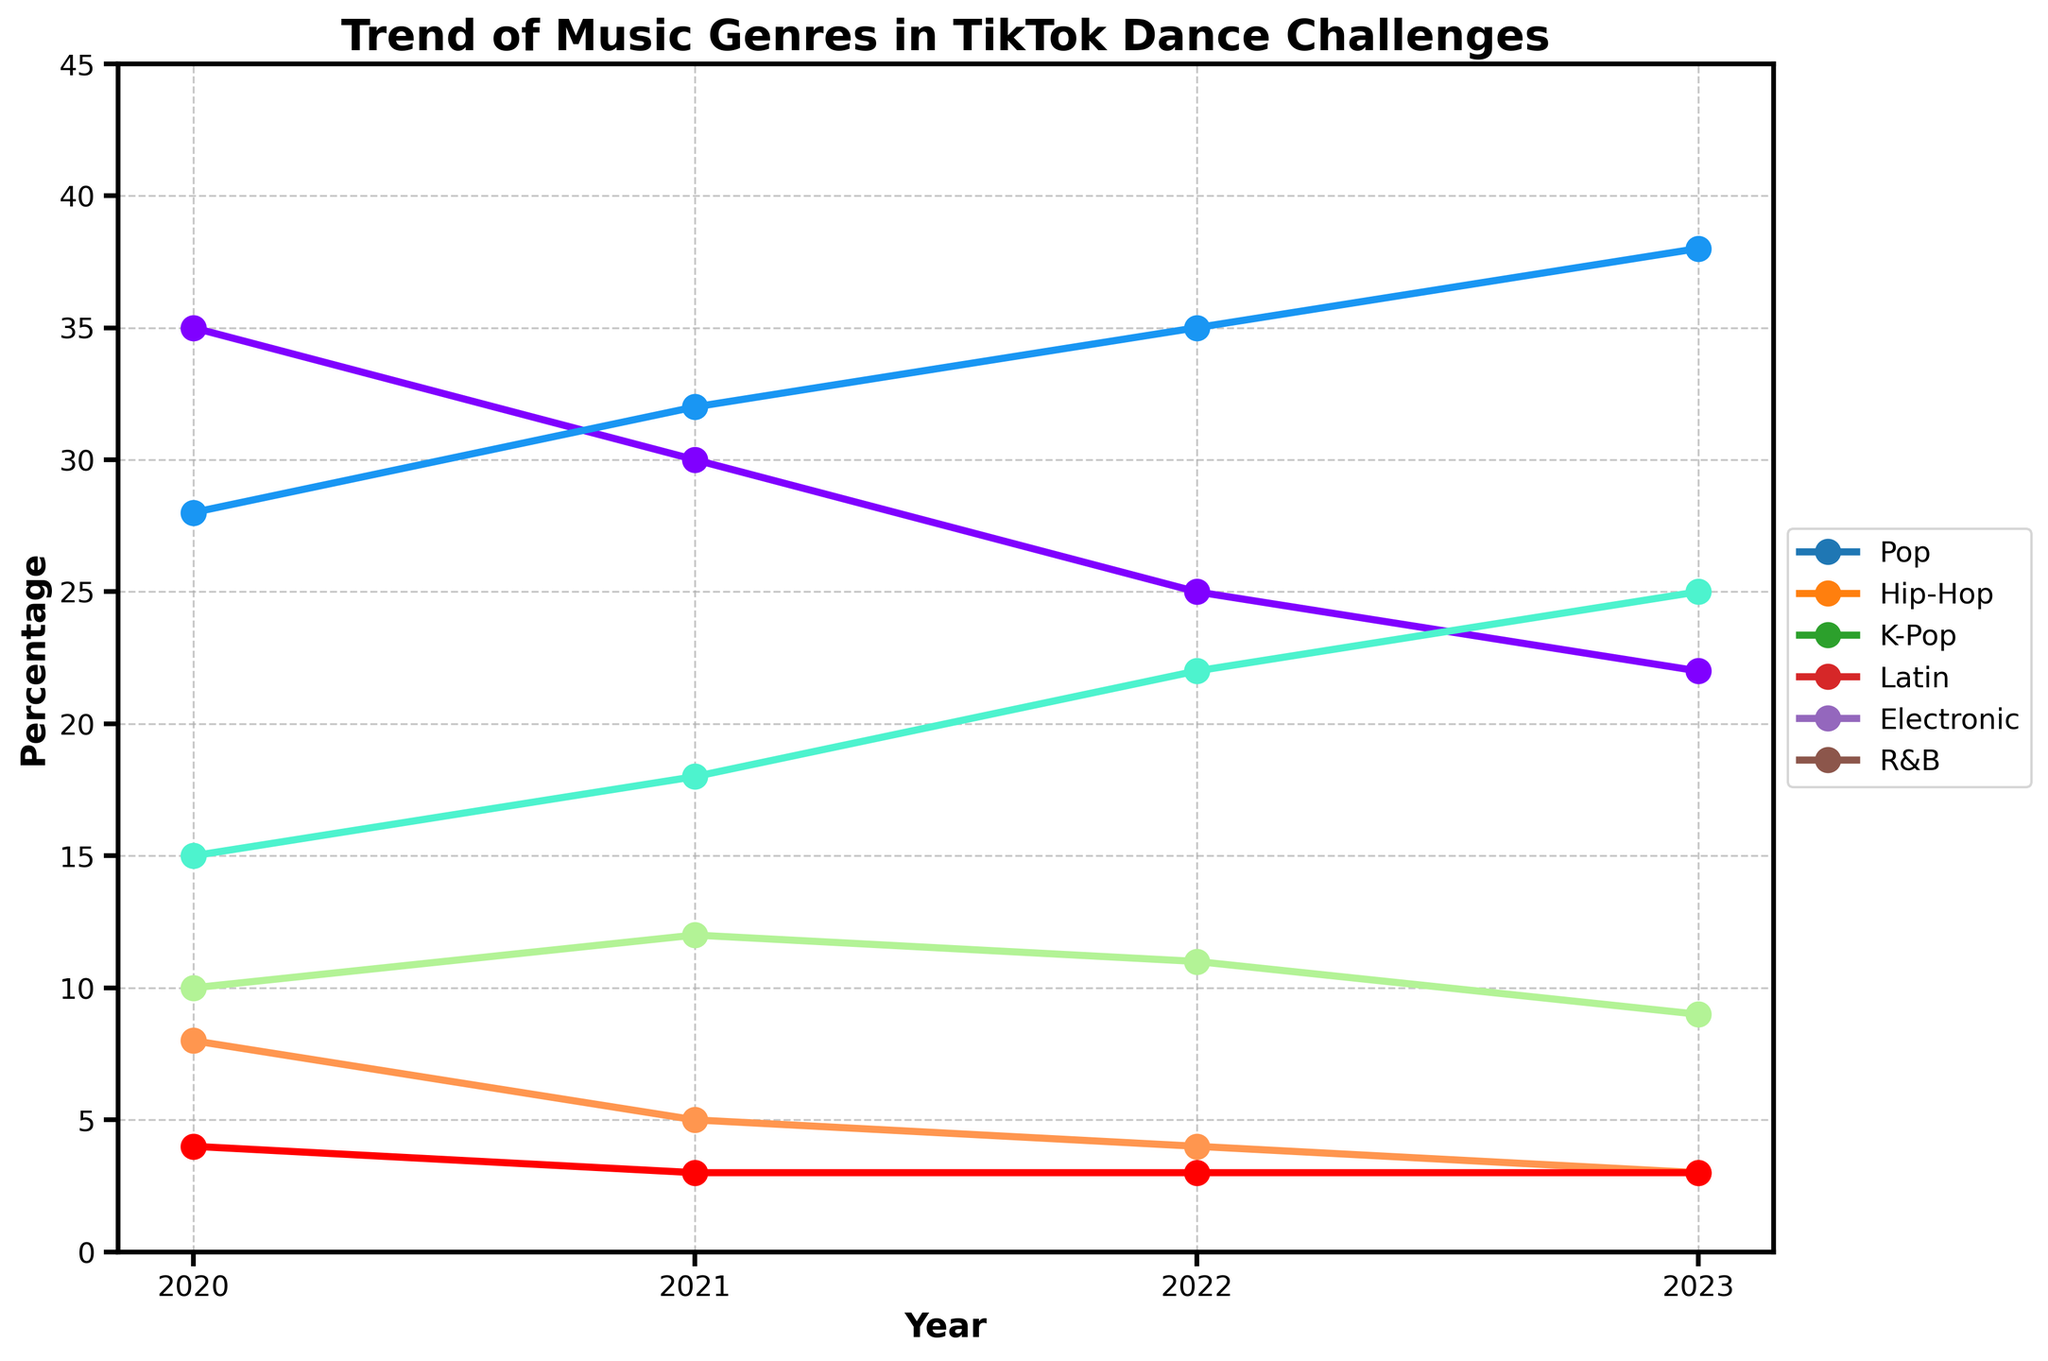Which genre saw the biggest increase in popularity from 2020 to 2023? To find the genre with the biggest increase, subtract the percentage of each genre in 2020 from its percentage in 2023 and compare the differences. Hip-Hop increased from 28% to 38%, which is an increase of 10%.
Answer: Hip-Hop Which genre had a consistent increase in popularity every year? By examining the trends from 2020 to 2023, check for a genre where the percentage increases each year. Hip-Hop consistently increased from 28% in 2020 to 38% in 2023.
Answer: Hip-Hop What is the average percentage of Pop music used in the challenges over the past 4 years? Add the percentages for each year and divide by the number of years: (35 + 30 + 25 + 22) / 4 = 112 / 4 = 28.
Answer: 28 Which year had the highest percentage of K-Pop usage in TikTok dance challenges? Look at the data points for K-Pop across all the years. The highest value is 25% in 2023.
Answer: 2023 How did the popularity of Latin music change from 2020 to 2023? Subtract the percentage in 2020 from the percentage in 2023 for Latin music: 9% - 10% = -1%. The percentage decreased by 1%.
Answer: Decreased by 1% What is the median percentage of Electronic music over the 4 years? Arrange the percentages in ascending order: 3, 4, 5, 8. The median is the average of the two middle numbers: (4 + 5) / 2 = 4.5.
Answer: 4.5 Between Pop and K-Pop, which genre saw a bigger drop from 2020 to 2023? Calculate the drop for each: Pop (35 - 22 = 13) and K-Pop (15 - 25 = -10). Only Pop shows a drop of 13, while K-Pop increased.
Answer: Pop Which genre had the lowest percentage in any given year? Look through all the values in the dataset and find the lowest value, which is R&B with 3% in multiple years.
Answer: R&B Comparing 2020 and 2023, which genre had the smallest change in popularity percentage? Calculate the absolute difference for each genre over the years: Pop (13), Hip-Hop (10), K-Pop (10), Latin (1), Electronic (5), R&B (0). R&B had the smallest change, remaining constant at 3%.
Answer: R&B 